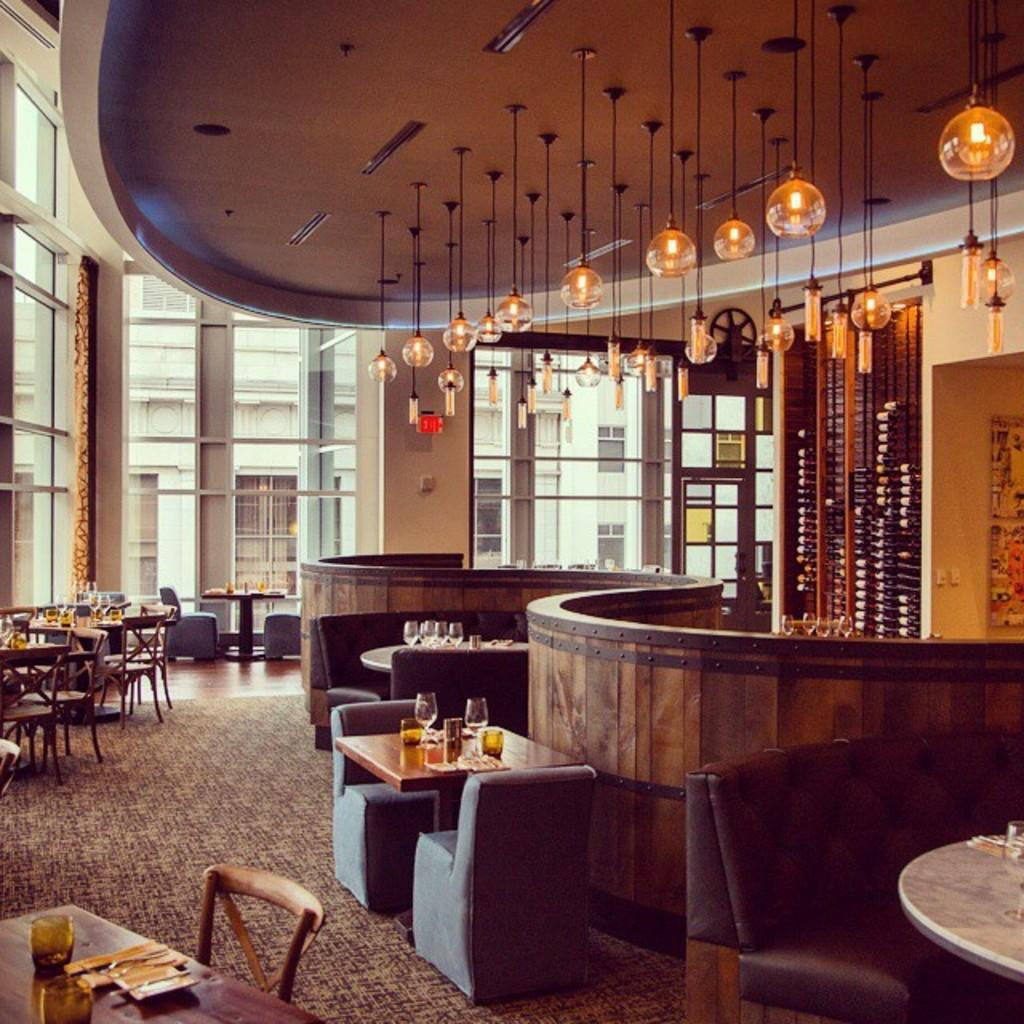What type of space is depicted in the image? The image shows an interior view of a building. What can be seen illuminating the space in the image? There are lights visible in the image. What type of furniture is present in the image? There are chairs and tables in the image. What objects are on the table in the image? There are glasses on the table. What part of the room can be seen in the image? The floor is visible in the image. What decision was made by the glasses on the table in the image? There are no decisions made by the glasses in the image, as they are inanimate objects. 